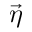<formula> <loc_0><loc_0><loc_500><loc_500>\vec { \eta }</formula> 